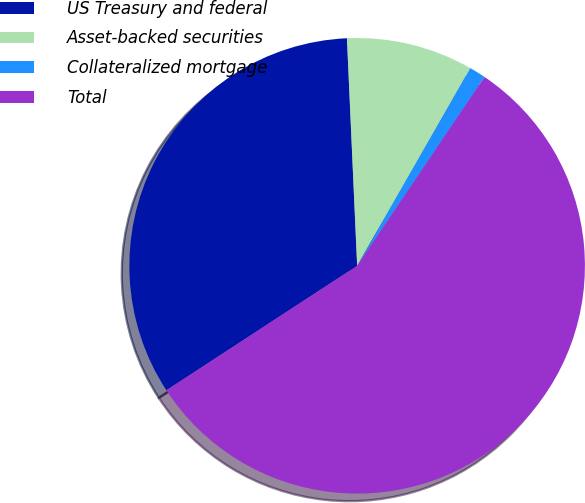<chart> <loc_0><loc_0><loc_500><loc_500><pie_chart><fcel>US Treasury and federal<fcel>Asset-backed securities<fcel>Collateralized mortgage<fcel>Total<nl><fcel>33.49%<fcel>8.99%<fcel>1.17%<fcel>56.35%<nl></chart> 